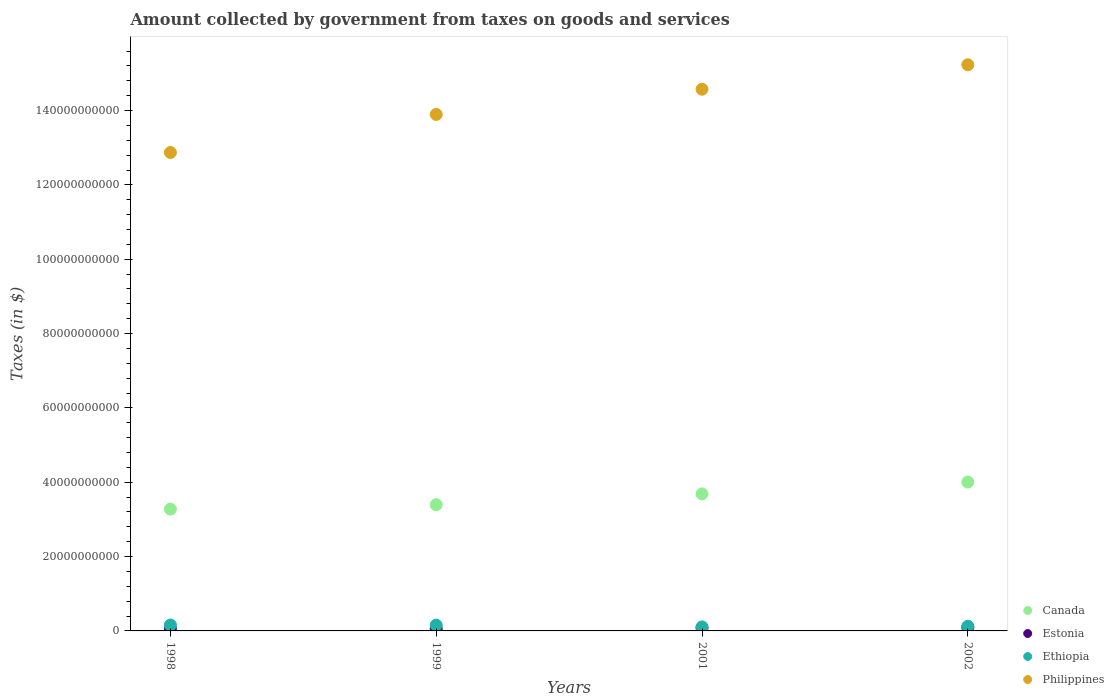How many different coloured dotlines are there?
Your answer should be very brief. 4. Is the number of dotlines equal to the number of legend labels?
Keep it short and to the point. Yes. What is the amount collected by government from taxes on goods and services in Estonia in 2002?
Provide a short and direct response. 9.37e+08. Across all years, what is the maximum amount collected by government from taxes on goods and services in Philippines?
Your answer should be compact. 1.52e+11. Across all years, what is the minimum amount collected by government from taxes on goods and services in Canada?
Your answer should be compact. 3.28e+1. In which year was the amount collected by government from taxes on goods and services in Ethiopia maximum?
Ensure brevity in your answer.  1998. What is the total amount collected by government from taxes on goods and services in Ethiopia in the graph?
Ensure brevity in your answer.  5.47e+09. What is the difference between the amount collected by government from taxes on goods and services in Philippines in 1998 and that in 2002?
Give a very brief answer. -2.36e+1. What is the difference between the amount collected by government from taxes on goods and services in Philippines in 1999 and the amount collected by government from taxes on goods and services in Estonia in 2001?
Give a very brief answer. 1.38e+11. What is the average amount collected by government from taxes on goods and services in Estonia per year?
Your response must be concise. 7.43e+08. In the year 2001, what is the difference between the amount collected by government from taxes on goods and services in Canada and amount collected by government from taxes on goods and services in Philippines?
Your answer should be very brief. -1.09e+11. What is the ratio of the amount collected by government from taxes on goods and services in Philippines in 1998 to that in 1999?
Give a very brief answer. 0.93. What is the difference between the highest and the second highest amount collected by government from taxes on goods and services in Ethiopia?
Your answer should be compact. 2.53e+07. What is the difference between the highest and the lowest amount collected by government from taxes on goods and services in Philippines?
Your answer should be compact. 2.36e+1. In how many years, is the amount collected by government from taxes on goods and services in Canada greater than the average amount collected by government from taxes on goods and services in Canada taken over all years?
Make the answer very short. 2. Is it the case that in every year, the sum of the amount collected by government from taxes on goods and services in Ethiopia and amount collected by government from taxes on goods and services in Estonia  is greater than the sum of amount collected by government from taxes on goods and services in Philippines and amount collected by government from taxes on goods and services in Canada?
Your response must be concise. No. Is the amount collected by government from taxes on goods and services in Ethiopia strictly greater than the amount collected by government from taxes on goods and services in Canada over the years?
Make the answer very short. No. How many dotlines are there?
Provide a short and direct response. 4. Does the graph contain grids?
Keep it short and to the point. No. Where does the legend appear in the graph?
Your response must be concise. Bottom right. What is the title of the graph?
Your response must be concise. Amount collected by government from taxes on goods and services. What is the label or title of the X-axis?
Keep it short and to the point. Years. What is the label or title of the Y-axis?
Your response must be concise. Taxes (in $). What is the Taxes (in $) of Canada in 1998?
Provide a short and direct response. 3.28e+1. What is the Taxes (in $) in Estonia in 1998?
Provide a short and direct response. 6.05e+08. What is the Taxes (in $) in Ethiopia in 1998?
Make the answer very short. 1.59e+09. What is the Taxes (in $) of Philippines in 1998?
Ensure brevity in your answer.  1.29e+11. What is the Taxes (in $) of Canada in 1999?
Keep it short and to the point. 3.39e+1. What is the Taxes (in $) of Estonia in 1999?
Offer a terse response. 6.03e+08. What is the Taxes (in $) in Ethiopia in 1999?
Keep it short and to the point. 1.56e+09. What is the Taxes (in $) in Philippines in 1999?
Provide a short and direct response. 1.39e+11. What is the Taxes (in $) of Canada in 2001?
Provide a short and direct response. 3.69e+1. What is the Taxes (in $) in Estonia in 2001?
Give a very brief answer. 8.27e+08. What is the Taxes (in $) of Ethiopia in 2001?
Your answer should be very brief. 1.08e+09. What is the Taxes (in $) of Philippines in 2001?
Ensure brevity in your answer.  1.46e+11. What is the Taxes (in $) in Canada in 2002?
Make the answer very short. 4.00e+1. What is the Taxes (in $) in Estonia in 2002?
Ensure brevity in your answer.  9.37e+08. What is the Taxes (in $) in Ethiopia in 2002?
Provide a short and direct response. 1.25e+09. What is the Taxes (in $) of Philippines in 2002?
Keep it short and to the point. 1.52e+11. Across all years, what is the maximum Taxes (in $) of Canada?
Give a very brief answer. 4.00e+1. Across all years, what is the maximum Taxes (in $) in Estonia?
Your answer should be compact. 9.37e+08. Across all years, what is the maximum Taxes (in $) of Ethiopia?
Provide a succinct answer. 1.59e+09. Across all years, what is the maximum Taxes (in $) in Philippines?
Offer a very short reply. 1.52e+11. Across all years, what is the minimum Taxes (in $) in Canada?
Make the answer very short. 3.28e+1. Across all years, what is the minimum Taxes (in $) in Estonia?
Provide a succinct answer. 6.03e+08. Across all years, what is the minimum Taxes (in $) of Ethiopia?
Offer a very short reply. 1.08e+09. Across all years, what is the minimum Taxes (in $) of Philippines?
Offer a very short reply. 1.29e+11. What is the total Taxes (in $) in Canada in the graph?
Offer a very short reply. 1.44e+11. What is the total Taxes (in $) of Estonia in the graph?
Make the answer very short. 2.97e+09. What is the total Taxes (in $) in Ethiopia in the graph?
Ensure brevity in your answer.  5.47e+09. What is the total Taxes (in $) of Philippines in the graph?
Your response must be concise. 5.66e+11. What is the difference between the Taxes (in $) in Canada in 1998 and that in 1999?
Your answer should be very brief. -1.17e+09. What is the difference between the Taxes (in $) in Estonia in 1998 and that in 1999?
Offer a terse response. 1.74e+06. What is the difference between the Taxes (in $) in Ethiopia in 1998 and that in 1999?
Your answer should be very brief. 2.53e+07. What is the difference between the Taxes (in $) in Philippines in 1998 and that in 1999?
Give a very brief answer. -1.02e+1. What is the difference between the Taxes (in $) in Canada in 1998 and that in 2001?
Offer a very short reply. -4.09e+09. What is the difference between the Taxes (in $) of Estonia in 1998 and that in 2001?
Offer a terse response. -2.23e+08. What is the difference between the Taxes (in $) in Ethiopia in 1998 and that in 2001?
Provide a short and direct response. 5.09e+08. What is the difference between the Taxes (in $) in Philippines in 1998 and that in 2001?
Provide a succinct answer. -1.70e+1. What is the difference between the Taxes (in $) of Canada in 1998 and that in 2002?
Offer a terse response. -7.27e+09. What is the difference between the Taxes (in $) in Estonia in 1998 and that in 2002?
Ensure brevity in your answer.  -3.32e+08. What is the difference between the Taxes (in $) of Ethiopia in 1998 and that in 2002?
Provide a short and direct response. 3.39e+08. What is the difference between the Taxes (in $) in Philippines in 1998 and that in 2002?
Make the answer very short. -2.36e+1. What is the difference between the Taxes (in $) in Canada in 1999 and that in 2001?
Provide a short and direct response. -2.92e+09. What is the difference between the Taxes (in $) of Estonia in 1999 and that in 2001?
Make the answer very short. -2.24e+08. What is the difference between the Taxes (in $) in Ethiopia in 1999 and that in 2001?
Give a very brief answer. 4.84e+08. What is the difference between the Taxes (in $) in Philippines in 1999 and that in 2001?
Provide a succinct answer. -6.78e+09. What is the difference between the Taxes (in $) of Canada in 1999 and that in 2002?
Offer a terse response. -6.10e+09. What is the difference between the Taxes (in $) of Estonia in 1999 and that in 2002?
Provide a short and direct response. -3.34e+08. What is the difference between the Taxes (in $) in Ethiopia in 1999 and that in 2002?
Ensure brevity in your answer.  3.14e+08. What is the difference between the Taxes (in $) in Philippines in 1999 and that in 2002?
Offer a terse response. -1.34e+1. What is the difference between the Taxes (in $) in Canada in 2001 and that in 2002?
Provide a succinct answer. -3.18e+09. What is the difference between the Taxes (in $) in Estonia in 2001 and that in 2002?
Your answer should be very brief. -1.10e+08. What is the difference between the Taxes (in $) in Ethiopia in 2001 and that in 2002?
Provide a succinct answer. -1.70e+08. What is the difference between the Taxes (in $) of Philippines in 2001 and that in 2002?
Offer a very short reply. -6.58e+09. What is the difference between the Taxes (in $) in Canada in 1998 and the Taxes (in $) in Estonia in 1999?
Give a very brief answer. 3.22e+1. What is the difference between the Taxes (in $) in Canada in 1998 and the Taxes (in $) in Ethiopia in 1999?
Offer a very short reply. 3.12e+1. What is the difference between the Taxes (in $) in Canada in 1998 and the Taxes (in $) in Philippines in 1999?
Give a very brief answer. -1.06e+11. What is the difference between the Taxes (in $) in Estonia in 1998 and the Taxes (in $) in Ethiopia in 1999?
Ensure brevity in your answer.  -9.56e+08. What is the difference between the Taxes (in $) in Estonia in 1998 and the Taxes (in $) in Philippines in 1999?
Provide a succinct answer. -1.38e+11. What is the difference between the Taxes (in $) in Ethiopia in 1998 and the Taxes (in $) in Philippines in 1999?
Give a very brief answer. -1.37e+11. What is the difference between the Taxes (in $) in Canada in 1998 and the Taxes (in $) in Estonia in 2001?
Give a very brief answer. 3.19e+1. What is the difference between the Taxes (in $) of Canada in 1998 and the Taxes (in $) of Ethiopia in 2001?
Your answer should be compact. 3.17e+1. What is the difference between the Taxes (in $) of Canada in 1998 and the Taxes (in $) of Philippines in 2001?
Keep it short and to the point. -1.13e+11. What is the difference between the Taxes (in $) in Estonia in 1998 and the Taxes (in $) in Ethiopia in 2001?
Provide a succinct answer. -4.73e+08. What is the difference between the Taxes (in $) of Estonia in 1998 and the Taxes (in $) of Philippines in 2001?
Offer a terse response. -1.45e+11. What is the difference between the Taxes (in $) in Ethiopia in 1998 and the Taxes (in $) in Philippines in 2001?
Make the answer very short. -1.44e+11. What is the difference between the Taxes (in $) in Canada in 1998 and the Taxes (in $) in Estonia in 2002?
Offer a very short reply. 3.18e+1. What is the difference between the Taxes (in $) in Canada in 1998 and the Taxes (in $) in Ethiopia in 2002?
Offer a terse response. 3.15e+1. What is the difference between the Taxes (in $) in Canada in 1998 and the Taxes (in $) in Philippines in 2002?
Keep it short and to the point. -1.20e+11. What is the difference between the Taxes (in $) in Estonia in 1998 and the Taxes (in $) in Ethiopia in 2002?
Make the answer very short. -6.43e+08. What is the difference between the Taxes (in $) of Estonia in 1998 and the Taxes (in $) of Philippines in 2002?
Your response must be concise. -1.52e+11. What is the difference between the Taxes (in $) of Ethiopia in 1998 and the Taxes (in $) of Philippines in 2002?
Offer a terse response. -1.51e+11. What is the difference between the Taxes (in $) of Canada in 1999 and the Taxes (in $) of Estonia in 2001?
Your answer should be compact. 3.31e+1. What is the difference between the Taxes (in $) of Canada in 1999 and the Taxes (in $) of Ethiopia in 2001?
Give a very brief answer. 3.29e+1. What is the difference between the Taxes (in $) in Canada in 1999 and the Taxes (in $) in Philippines in 2001?
Give a very brief answer. -1.12e+11. What is the difference between the Taxes (in $) of Estonia in 1999 and the Taxes (in $) of Ethiopia in 2001?
Provide a succinct answer. -4.75e+08. What is the difference between the Taxes (in $) in Estonia in 1999 and the Taxes (in $) in Philippines in 2001?
Keep it short and to the point. -1.45e+11. What is the difference between the Taxes (in $) of Ethiopia in 1999 and the Taxes (in $) of Philippines in 2001?
Your response must be concise. -1.44e+11. What is the difference between the Taxes (in $) of Canada in 1999 and the Taxes (in $) of Estonia in 2002?
Provide a short and direct response. 3.30e+1. What is the difference between the Taxes (in $) of Canada in 1999 and the Taxes (in $) of Ethiopia in 2002?
Offer a very short reply. 3.27e+1. What is the difference between the Taxes (in $) of Canada in 1999 and the Taxes (in $) of Philippines in 2002?
Provide a succinct answer. -1.18e+11. What is the difference between the Taxes (in $) in Estonia in 1999 and the Taxes (in $) in Ethiopia in 2002?
Your response must be concise. -6.45e+08. What is the difference between the Taxes (in $) in Estonia in 1999 and the Taxes (in $) in Philippines in 2002?
Ensure brevity in your answer.  -1.52e+11. What is the difference between the Taxes (in $) in Ethiopia in 1999 and the Taxes (in $) in Philippines in 2002?
Your answer should be very brief. -1.51e+11. What is the difference between the Taxes (in $) of Canada in 2001 and the Taxes (in $) of Estonia in 2002?
Ensure brevity in your answer.  3.59e+1. What is the difference between the Taxes (in $) in Canada in 2001 and the Taxes (in $) in Ethiopia in 2002?
Make the answer very short. 3.56e+1. What is the difference between the Taxes (in $) in Canada in 2001 and the Taxes (in $) in Philippines in 2002?
Provide a short and direct response. -1.15e+11. What is the difference between the Taxes (in $) in Estonia in 2001 and the Taxes (in $) in Ethiopia in 2002?
Your answer should be compact. -4.20e+08. What is the difference between the Taxes (in $) of Estonia in 2001 and the Taxes (in $) of Philippines in 2002?
Offer a terse response. -1.51e+11. What is the difference between the Taxes (in $) in Ethiopia in 2001 and the Taxes (in $) in Philippines in 2002?
Keep it short and to the point. -1.51e+11. What is the average Taxes (in $) in Canada per year?
Offer a terse response. 3.59e+1. What is the average Taxes (in $) of Estonia per year?
Ensure brevity in your answer.  7.43e+08. What is the average Taxes (in $) of Ethiopia per year?
Your answer should be compact. 1.37e+09. What is the average Taxes (in $) of Philippines per year?
Provide a succinct answer. 1.41e+11. In the year 1998, what is the difference between the Taxes (in $) in Canada and Taxes (in $) in Estonia?
Make the answer very short. 3.22e+1. In the year 1998, what is the difference between the Taxes (in $) of Canada and Taxes (in $) of Ethiopia?
Keep it short and to the point. 3.12e+1. In the year 1998, what is the difference between the Taxes (in $) of Canada and Taxes (in $) of Philippines?
Your answer should be compact. -9.59e+1. In the year 1998, what is the difference between the Taxes (in $) of Estonia and Taxes (in $) of Ethiopia?
Provide a short and direct response. -9.82e+08. In the year 1998, what is the difference between the Taxes (in $) of Estonia and Taxes (in $) of Philippines?
Offer a very short reply. -1.28e+11. In the year 1998, what is the difference between the Taxes (in $) in Ethiopia and Taxes (in $) in Philippines?
Ensure brevity in your answer.  -1.27e+11. In the year 1999, what is the difference between the Taxes (in $) of Canada and Taxes (in $) of Estonia?
Keep it short and to the point. 3.33e+1. In the year 1999, what is the difference between the Taxes (in $) of Canada and Taxes (in $) of Ethiopia?
Provide a succinct answer. 3.24e+1. In the year 1999, what is the difference between the Taxes (in $) in Canada and Taxes (in $) in Philippines?
Offer a very short reply. -1.05e+11. In the year 1999, what is the difference between the Taxes (in $) of Estonia and Taxes (in $) of Ethiopia?
Your response must be concise. -9.58e+08. In the year 1999, what is the difference between the Taxes (in $) in Estonia and Taxes (in $) in Philippines?
Your response must be concise. -1.38e+11. In the year 1999, what is the difference between the Taxes (in $) of Ethiopia and Taxes (in $) of Philippines?
Your answer should be very brief. -1.37e+11. In the year 2001, what is the difference between the Taxes (in $) in Canada and Taxes (in $) in Estonia?
Offer a very short reply. 3.60e+1. In the year 2001, what is the difference between the Taxes (in $) in Canada and Taxes (in $) in Ethiopia?
Offer a very short reply. 3.58e+1. In the year 2001, what is the difference between the Taxes (in $) of Canada and Taxes (in $) of Philippines?
Make the answer very short. -1.09e+11. In the year 2001, what is the difference between the Taxes (in $) of Estonia and Taxes (in $) of Ethiopia?
Provide a short and direct response. -2.50e+08. In the year 2001, what is the difference between the Taxes (in $) of Estonia and Taxes (in $) of Philippines?
Your response must be concise. -1.45e+11. In the year 2001, what is the difference between the Taxes (in $) in Ethiopia and Taxes (in $) in Philippines?
Your answer should be very brief. -1.45e+11. In the year 2002, what is the difference between the Taxes (in $) of Canada and Taxes (in $) of Estonia?
Your answer should be compact. 3.91e+1. In the year 2002, what is the difference between the Taxes (in $) in Canada and Taxes (in $) in Ethiopia?
Your answer should be very brief. 3.88e+1. In the year 2002, what is the difference between the Taxes (in $) of Canada and Taxes (in $) of Philippines?
Your response must be concise. -1.12e+11. In the year 2002, what is the difference between the Taxes (in $) in Estonia and Taxes (in $) in Ethiopia?
Offer a very short reply. -3.11e+08. In the year 2002, what is the difference between the Taxes (in $) in Estonia and Taxes (in $) in Philippines?
Ensure brevity in your answer.  -1.51e+11. In the year 2002, what is the difference between the Taxes (in $) in Ethiopia and Taxes (in $) in Philippines?
Offer a terse response. -1.51e+11. What is the ratio of the Taxes (in $) of Canada in 1998 to that in 1999?
Offer a very short reply. 0.97. What is the ratio of the Taxes (in $) in Ethiopia in 1998 to that in 1999?
Give a very brief answer. 1.02. What is the ratio of the Taxes (in $) of Philippines in 1998 to that in 1999?
Provide a short and direct response. 0.93. What is the ratio of the Taxes (in $) in Canada in 1998 to that in 2001?
Keep it short and to the point. 0.89. What is the ratio of the Taxes (in $) of Estonia in 1998 to that in 2001?
Provide a succinct answer. 0.73. What is the ratio of the Taxes (in $) of Ethiopia in 1998 to that in 2001?
Provide a succinct answer. 1.47. What is the ratio of the Taxes (in $) of Philippines in 1998 to that in 2001?
Keep it short and to the point. 0.88. What is the ratio of the Taxes (in $) in Canada in 1998 to that in 2002?
Provide a short and direct response. 0.82. What is the ratio of the Taxes (in $) of Estonia in 1998 to that in 2002?
Your answer should be very brief. 0.65. What is the ratio of the Taxes (in $) in Ethiopia in 1998 to that in 2002?
Make the answer very short. 1.27. What is the ratio of the Taxes (in $) in Philippines in 1998 to that in 2002?
Offer a terse response. 0.84. What is the ratio of the Taxes (in $) of Canada in 1999 to that in 2001?
Make the answer very short. 0.92. What is the ratio of the Taxes (in $) in Estonia in 1999 to that in 2001?
Ensure brevity in your answer.  0.73. What is the ratio of the Taxes (in $) in Ethiopia in 1999 to that in 2001?
Keep it short and to the point. 1.45. What is the ratio of the Taxes (in $) in Philippines in 1999 to that in 2001?
Offer a terse response. 0.95. What is the ratio of the Taxes (in $) of Canada in 1999 to that in 2002?
Offer a terse response. 0.85. What is the ratio of the Taxes (in $) in Estonia in 1999 to that in 2002?
Offer a very short reply. 0.64. What is the ratio of the Taxes (in $) in Ethiopia in 1999 to that in 2002?
Provide a short and direct response. 1.25. What is the ratio of the Taxes (in $) of Philippines in 1999 to that in 2002?
Your response must be concise. 0.91. What is the ratio of the Taxes (in $) of Canada in 2001 to that in 2002?
Your answer should be very brief. 0.92. What is the ratio of the Taxes (in $) in Estonia in 2001 to that in 2002?
Provide a short and direct response. 0.88. What is the ratio of the Taxes (in $) of Ethiopia in 2001 to that in 2002?
Provide a succinct answer. 0.86. What is the ratio of the Taxes (in $) in Philippines in 2001 to that in 2002?
Your answer should be compact. 0.96. What is the difference between the highest and the second highest Taxes (in $) in Canada?
Offer a very short reply. 3.18e+09. What is the difference between the highest and the second highest Taxes (in $) of Estonia?
Your answer should be compact. 1.10e+08. What is the difference between the highest and the second highest Taxes (in $) in Ethiopia?
Offer a terse response. 2.53e+07. What is the difference between the highest and the second highest Taxes (in $) of Philippines?
Offer a terse response. 6.58e+09. What is the difference between the highest and the lowest Taxes (in $) in Canada?
Give a very brief answer. 7.27e+09. What is the difference between the highest and the lowest Taxes (in $) of Estonia?
Keep it short and to the point. 3.34e+08. What is the difference between the highest and the lowest Taxes (in $) of Ethiopia?
Your answer should be compact. 5.09e+08. What is the difference between the highest and the lowest Taxes (in $) of Philippines?
Your answer should be compact. 2.36e+1. 